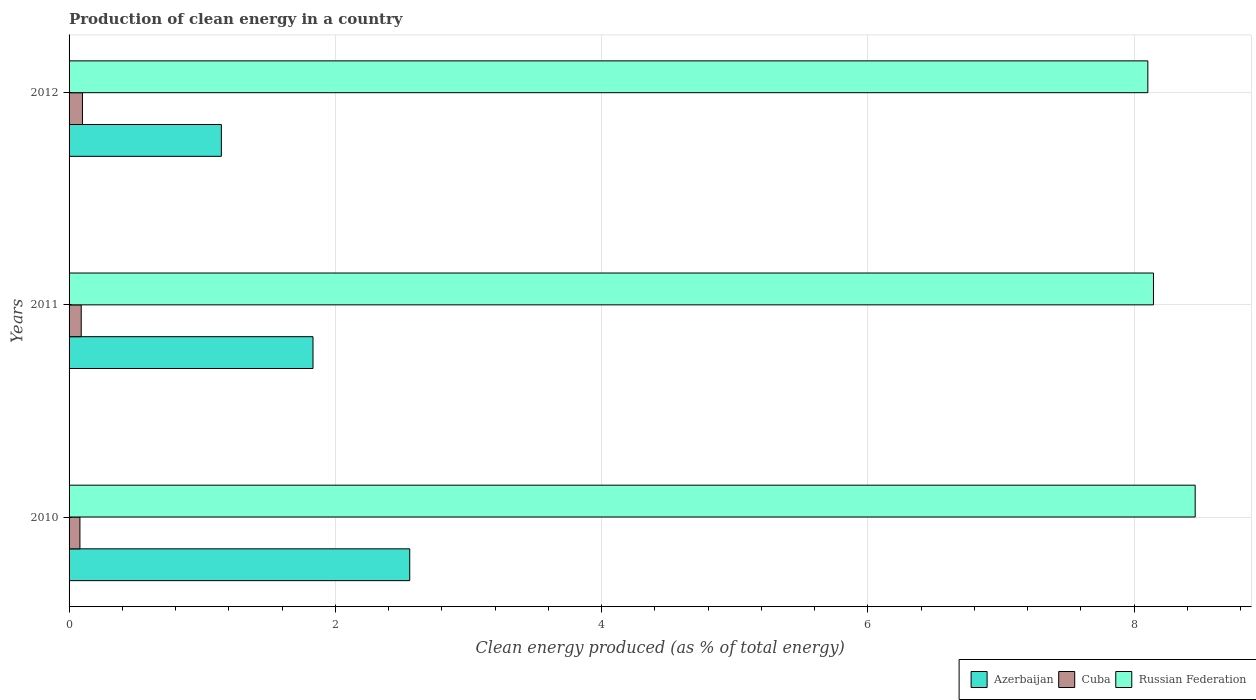How many different coloured bars are there?
Ensure brevity in your answer.  3. Are the number of bars per tick equal to the number of legend labels?
Provide a short and direct response. Yes. In how many cases, is the number of bars for a given year not equal to the number of legend labels?
Offer a terse response. 0. What is the percentage of clean energy produced in Cuba in 2012?
Your response must be concise. 0.1. Across all years, what is the maximum percentage of clean energy produced in Azerbaijan?
Provide a succinct answer. 2.56. Across all years, what is the minimum percentage of clean energy produced in Russian Federation?
Your response must be concise. 8.1. What is the total percentage of clean energy produced in Azerbaijan in the graph?
Offer a very short reply. 5.53. What is the difference between the percentage of clean energy produced in Russian Federation in 2010 and that in 2011?
Keep it short and to the point. 0.31. What is the difference between the percentage of clean energy produced in Russian Federation in 2010 and the percentage of clean energy produced in Cuba in 2011?
Your response must be concise. 8.37. What is the average percentage of clean energy produced in Azerbaijan per year?
Provide a succinct answer. 1.84. In the year 2011, what is the difference between the percentage of clean energy produced in Cuba and percentage of clean energy produced in Russian Federation?
Make the answer very short. -8.05. In how many years, is the percentage of clean energy produced in Azerbaijan greater than 6.4 %?
Give a very brief answer. 0. What is the ratio of the percentage of clean energy produced in Russian Federation in 2011 to that in 2012?
Provide a short and direct response. 1.01. Is the percentage of clean energy produced in Azerbaijan in 2011 less than that in 2012?
Your response must be concise. No. Is the difference between the percentage of clean energy produced in Cuba in 2010 and 2012 greater than the difference between the percentage of clean energy produced in Russian Federation in 2010 and 2012?
Provide a short and direct response. No. What is the difference between the highest and the second highest percentage of clean energy produced in Azerbaijan?
Ensure brevity in your answer.  0.73. What is the difference between the highest and the lowest percentage of clean energy produced in Russian Federation?
Make the answer very short. 0.36. Is the sum of the percentage of clean energy produced in Cuba in 2010 and 2011 greater than the maximum percentage of clean energy produced in Azerbaijan across all years?
Your answer should be compact. No. What does the 3rd bar from the top in 2012 represents?
Your answer should be very brief. Azerbaijan. What does the 1st bar from the bottom in 2012 represents?
Your answer should be very brief. Azerbaijan. Are all the bars in the graph horizontal?
Give a very brief answer. Yes. What is the difference between two consecutive major ticks on the X-axis?
Provide a succinct answer. 2. Are the values on the major ticks of X-axis written in scientific E-notation?
Keep it short and to the point. No. Does the graph contain any zero values?
Give a very brief answer. No. Where does the legend appear in the graph?
Your answer should be very brief. Bottom right. How many legend labels are there?
Give a very brief answer. 3. What is the title of the graph?
Make the answer very short. Production of clean energy in a country. Does "Thailand" appear as one of the legend labels in the graph?
Ensure brevity in your answer.  No. What is the label or title of the X-axis?
Your answer should be compact. Clean energy produced (as % of total energy). What is the Clean energy produced (as % of total energy) in Azerbaijan in 2010?
Offer a terse response. 2.56. What is the Clean energy produced (as % of total energy) of Cuba in 2010?
Your answer should be compact. 0.08. What is the Clean energy produced (as % of total energy) of Russian Federation in 2010?
Make the answer very short. 8.46. What is the Clean energy produced (as % of total energy) of Azerbaijan in 2011?
Keep it short and to the point. 1.83. What is the Clean energy produced (as % of total energy) of Cuba in 2011?
Offer a terse response. 0.09. What is the Clean energy produced (as % of total energy) in Russian Federation in 2011?
Give a very brief answer. 8.14. What is the Clean energy produced (as % of total energy) in Azerbaijan in 2012?
Your answer should be very brief. 1.14. What is the Clean energy produced (as % of total energy) of Cuba in 2012?
Offer a terse response. 0.1. What is the Clean energy produced (as % of total energy) of Russian Federation in 2012?
Offer a very short reply. 8.1. Across all years, what is the maximum Clean energy produced (as % of total energy) in Azerbaijan?
Your answer should be compact. 2.56. Across all years, what is the maximum Clean energy produced (as % of total energy) of Cuba?
Give a very brief answer. 0.1. Across all years, what is the maximum Clean energy produced (as % of total energy) in Russian Federation?
Ensure brevity in your answer.  8.46. Across all years, what is the minimum Clean energy produced (as % of total energy) of Azerbaijan?
Offer a terse response. 1.14. Across all years, what is the minimum Clean energy produced (as % of total energy) of Cuba?
Keep it short and to the point. 0.08. Across all years, what is the minimum Clean energy produced (as % of total energy) in Russian Federation?
Your response must be concise. 8.1. What is the total Clean energy produced (as % of total energy) of Azerbaijan in the graph?
Your answer should be compact. 5.53. What is the total Clean energy produced (as % of total energy) in Cuba in the graph?
Provide a short and direct response. 0.27. What is the total Clean energy produced (as % of total energy) in Russian Federation in the graph?
Make the answer very short. 24.71. What is the difference between the Clean energy produced (as % of total energy) in Azerbaijan in 2010 and that in 2011?
Make the answer very short. 0.73. What is the difference between the Clean energy produced (as % of total energy) in Cuba in 2010 and that in 2011?
Your response must be concise. -0.01. What is the difference between the Clean energy produced (as % of total energy) in Russian Federation in 2010 and that in 2011?
Provide a short and direct response. 0.31. What is the difference between the Clean energy produced (as % of total energy) in Azerbaijan in 2010 and that in 2012?
Give a very brief answer. 1.41. What is the difference between the Clean energy produced (as % of total energy) of Cuba in 2010 and that in 2012?
Offer a very short reply. -0.02. What is the difference between the Clean energy produced (as % of total energy) in Russian Federation in 2010 and that in 2012?
Offer a terse response. 0.36. What is the difference between the Clean energy produced (as % of total energy) of Azerbaijan in 2011 and that in 2012?
Your response must be concise. 0.69. What is the difference between the Clean energy produced (as % of total energy) of Cuba in 2011 and that in 2012?
Ensure brevity in your answer.  -0.01. What is the difference between the Clean energy produced (as % of total energy) of Russian Federation in 2011 and that in 2012?
Your answer should be compact. 0.04. What is the difference between the Clean energy produced (as % of total energy) of Azerbaijan in 2010 and the Clean energy produced (as % of total energy) of Cuba in 2011?
Provide a succinct answer. 2.47. What is the difference between the Clean energy produced (as % of total energy) in Azerbaijan in 2010 and the Clean energy produced (as % of total energy) in Russian Federation in 2011?
Ensure brevity in your answer.  -5.59. What is the difference between the Clean energy produced (as % of total energy) in Cuba in 2010 and the Clean energy produced (as % of total energy) in Russian Federation in 2011?
Offer a terse response. -8.06. What is the difference between the Clean energy produced (as % of total energy) of Azerbaijan in 2010 and the Clean energy produced (as % of total energy) of Cuba in 2012?
Provide a succinct answer. 2.46. What is the difference between the Clean energy produced (as % of total energy) of Azerbaijan in 2010 and the Clean energy produced (as % of total energy) of Russian Federation in 2012?
Your response must be concise. -5.54. What is the difference between the Clean energy produced (as % of total energy) of Cuba in 2010 and the Clean energy produced (as % of total energy) of Russian Federation in 2012?
Keep it short and to the point. -8.02. What is the difference between the Clean energy produced (as % of total energy) in Azerbaijan in 2011 and the Clean energy produced (as % of total energy) in Cuba in 2012?
Ensure brevity in your answer.  1.73. What is the difference between the Clean energy produced (as % of total energy) of Azerbaijan in 2011 and the Clean energy produced (as % of total energy) of Russian Federation in 2012?
Your answer should be compact. -6.27. What is the difference between the Clean energy produced (as % of total energy) of Cuba in 2011 and the Clean energy produced (as % of total energy) of Russian Federation in 2012?
Your answer should be compact. -8.01. What is the average Clean energy produced (as % of total energy) of Azerbaijan per year?
Your answer should be very brief. 1.84. What is the average Clean energy produced (as % of total energy) of Cuba per year?
Offer a very short reply. 0.09. What is the average Clean energy produced (as % of total energy) of Russian Federation per year?
Make the answer very short. 8.24. In the year 2010, what is the difference between the Clean energy produced (as % of total energy) in Azerbaijan and Clean energy produced (as % of total energy) in Cuba?
Your response must be concise. 2.48. In the year 2010, what is the difference between the Clean energy produced (as % of total energy) in Azerbaijan and Clean energy produced (as % of total energy) in Russian Federation?
Offer a very short reply. -5.9. In the year 2010, what is the difference between the Clean energy produced (as % of total energy) of Cuba and Clean energy produced (as % of total energy) of Russian Federation?
Make the answer very short. -8.38. In the year 2011, what is the difference between the Clean energy produced (as % of total energy) in Azerbaijan and Clean energy produced (as % of total energy) in Cuba?
Provide a succinct answer. 1.74. In the year 2011, what is the difference between the Clean energy produced (as % of total energy) in Azerbaijan and Clean energy produced (as % of total energy) in Russian Federation?
Keep it short and to the point. -6.31. In the year 2011, what is the difference between the Clean energy produced (as % of total energy) in Cuba and Clean energy produced (as % of total energy) in Russian Federation?
Provide a succinct answer. -8.05. In the year 2012, what is the difference between the Clean energy produced (as % of total energy) in Azerbaijan and Clean energy produced (as % of total energy) in Cuba?
Provide a short and direct response. 1.04. In the year 2012, what is the difference between the Clean energy produced (as % of total energy) of Azerbaijan and Clean energy produced (as % of total energy) of Russian Federation?
Your answer should be very brief. -6.96. In the year 2012, what is the difference between the Clean energy produced (as % of total energy) of Cuba and Clean energy produced (as % of total energy) of Russian Federation?
Your response must be concise. -8. What is the ratio of the Clean energy produced (as % of total energy) of Azerbaijan in 2010 to that in 2011?
Your answer should be very brief. 1.4. What is the ratio of the Clean energy produced (as % of total energy) of Cuba in 2010 to that in 2011?
Make the answer very short. 0.89. What is the ratio of the Clean energy produced (as % of total energy) in Russian Federation in 2010 to that in 2011?
Make the answer very short. 1.04. What is the ratio of the Clean energy produced (as % of total energy) of Azerbaijan in 2010 to that in 2012?
Provide a short and direct response. 2.24. What is the ratio of the Clean energy produced (as % of total energy) of Cuba in 2010 to that in 2012?
Give a very brief answer. 0.81. What is the ratio of the Clean energy produced (as % of total energy) of Russian Federation in 2010 to that in 2012?
Offer a very short reply. 1.04. What is the ratio of the Clean energy produced (as % of total energy) of Azerbaijan in 2011 to that in 2012?
Provide a short and direct response. 1.6. What is the ratio of the Clean energy produced (as % of total energy) in Cuba in 2011 to that in 2012?
Offer a terse response. 0.91. What is the difference between the highest and the second highest Clean energy produced (as % of total energy) in Azerbaijan?
Keep it short and to the point. 0.73. What is the difference between the highest and the second highest Clean energy produced (as % of total energy) of Cuba?
Offer a terse response. 0.01. What is the difference between the highest and the second highest Clean energy produced (as % of total energy) in Russian Federation?
Provide a short and direct response. 0.31. What is the difference between the highest and the lowest Clean energy produced (as % of total energy) in Azerbaijan?
Provide a short and direct response. 1.41. What is the difference between the highest and the lowest Clean energy produced (as % of total energy) in Cuba?
Make the answer very short. 0.02. What is the difference between the highest and the lowest Clean energy produced (as % of total energy) in Russian Federation?
Your response must be concise. 0.36. 